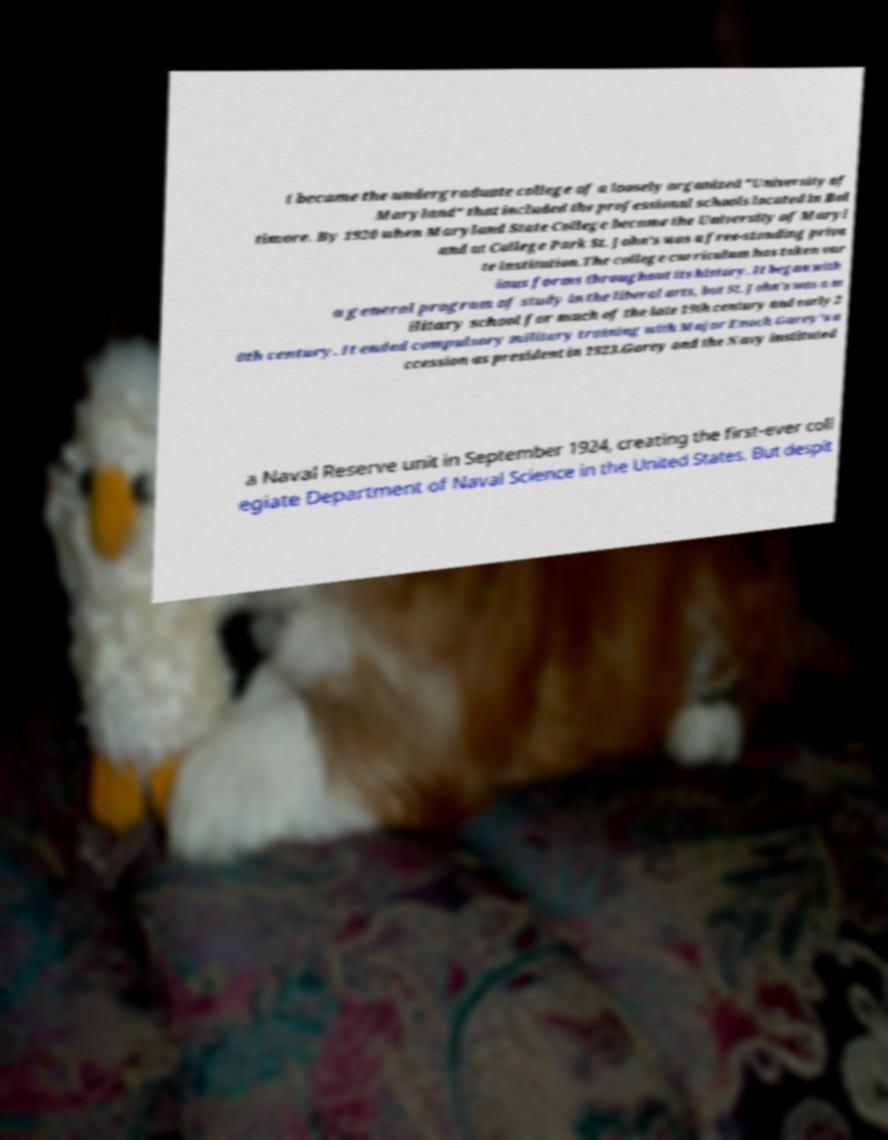Please identify and transcribe the text found in this image. t became the undergraduate college of a loosely organized "University of Maryland" that included the professional schools located in Bal timore. By 1920 when Maryland State College became the University of Maryl and at College Park St. John's was a free-standing priva te institution.The college curriculum has taken var ious forms throughout its history. It began with a general program of study in the liberal arts, but St. John's was a m ilitary school for much of the late 19th century and early 2 0th century. It ended compulsory military training with Major Enoch Garey's a ccession as president in 1923.Garey and the Navy instituted a Naval Reserve unit in September 1924, creating the first-ever coll egiate Department of Naval Science in the United States. But despit 